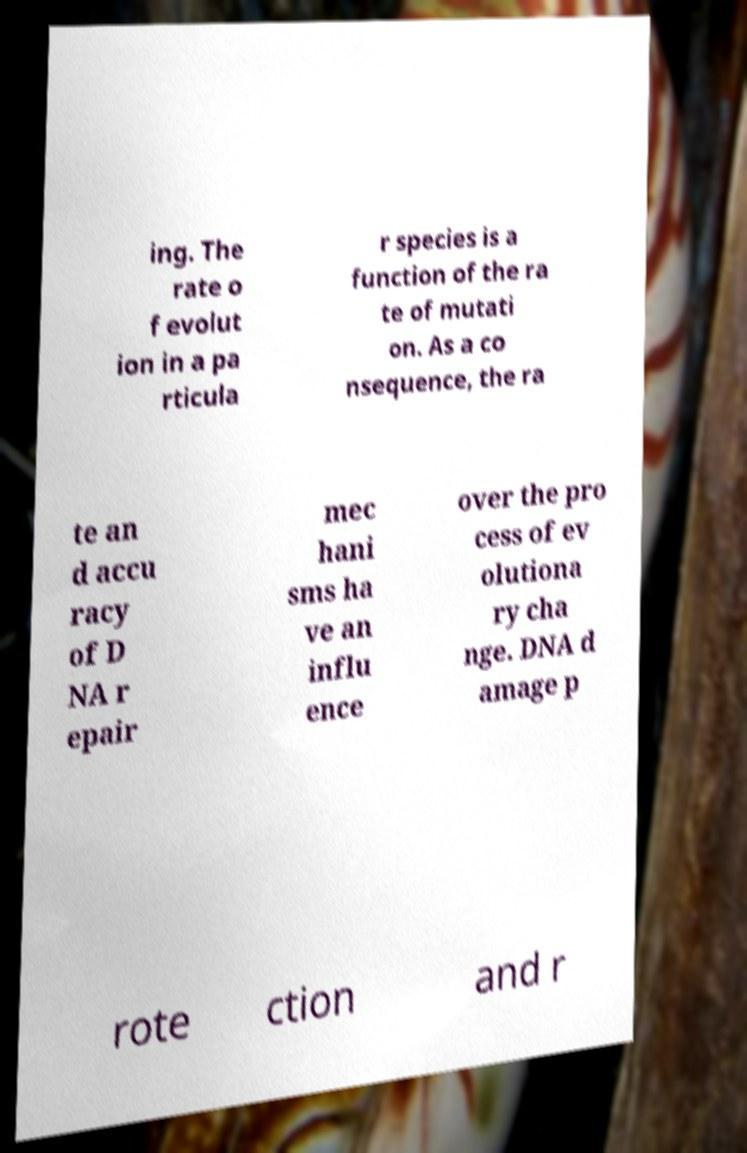Can you read and provide the text displayed in the image?This photo seems to have some interesting text. Can you extract and type it out for me? ing. The rate o f evolut ion in a pa rticula r species is a function of the ra te of mutati on. As a co nsequence, the ra te an d accu racy of D NA r epair mec hani sms ha ve an influ ence over the pro cess of ev olutiona ry cha nge. DNA d amage p rote ction and r 